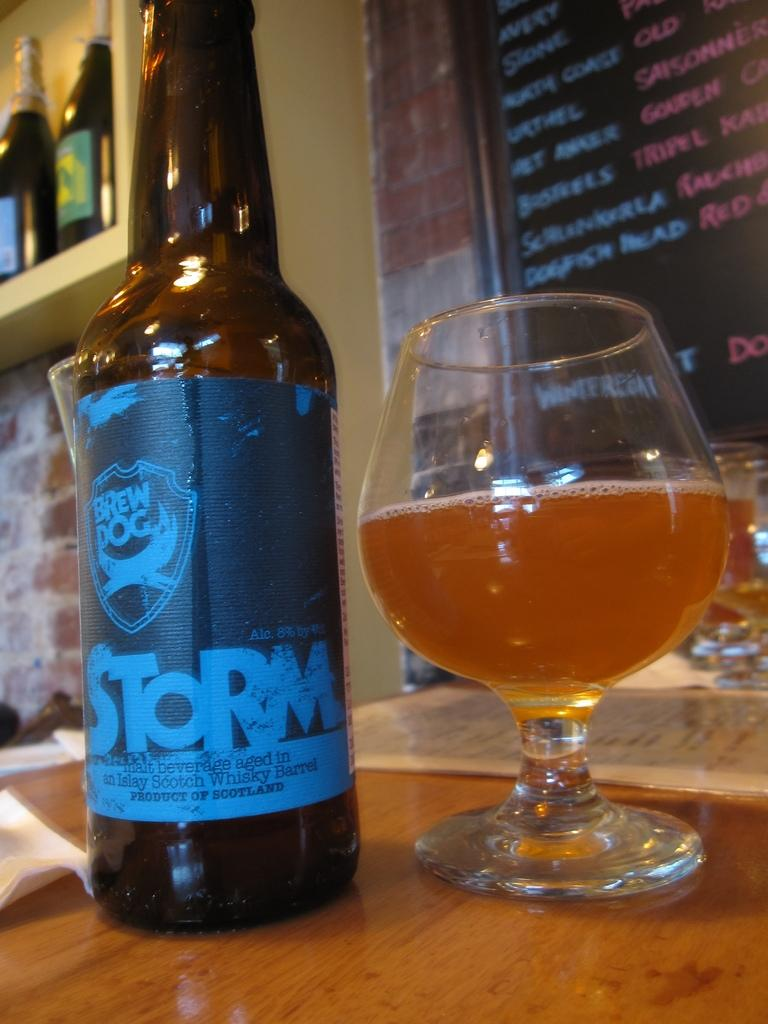Provide a one-sentence caption for the provided image. A half glass full of beer next to a bottle of beer from Brew Dog that says STORM. 